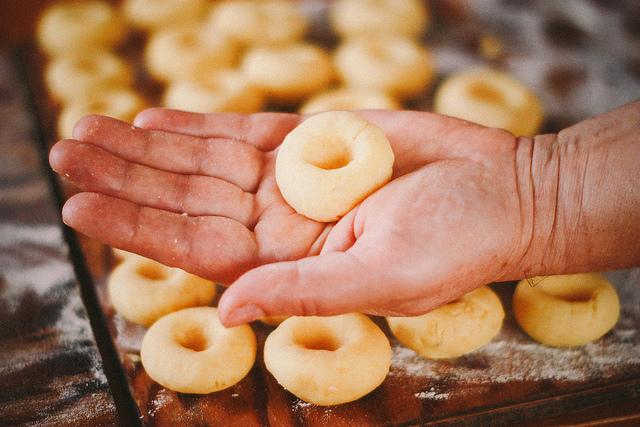What is the person making?
Give a very brief answer. Donuts. Which hand is that?
Write a very short answer. Left. Are those yeasted doughnuts?
Short answer required. Yes. How many cakes on in her hand?
Answer briefly. 1. 